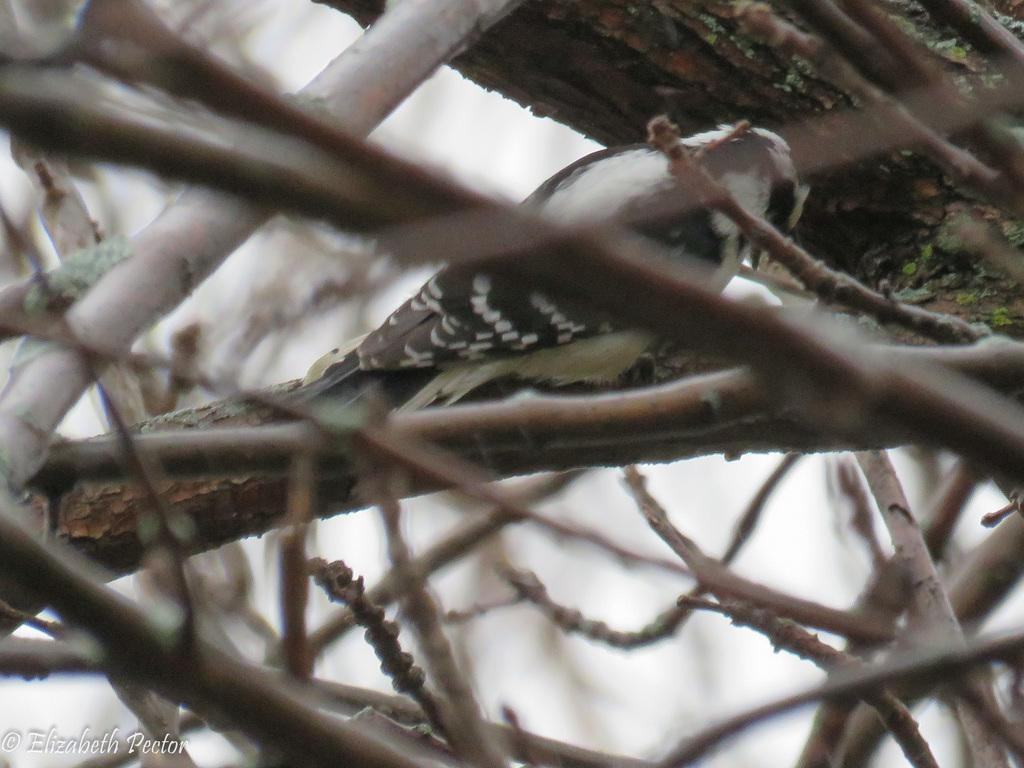What type of animal can be seen in the image? There is a bird in the image. Where is the bird located? The bird is on a tree branch. What can be seen in the foreground of the image? There are twigs in the foreground of the image. What language is the bird speaking in the image? Birds do not speak human languages, so it is not possible to determine what language the bird might be speaking in the image. 